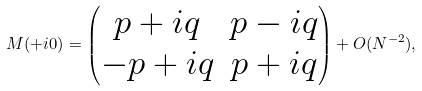<formula> <loc_0><loc_0><loc_500><loc_500>M ( + i 0 ) = \begin{pmatrix} p + i q & p - i q \\ - p + i q & p + i q \end{pmatrix} + O ( N ^ { - 2 } ) ,</formula> 